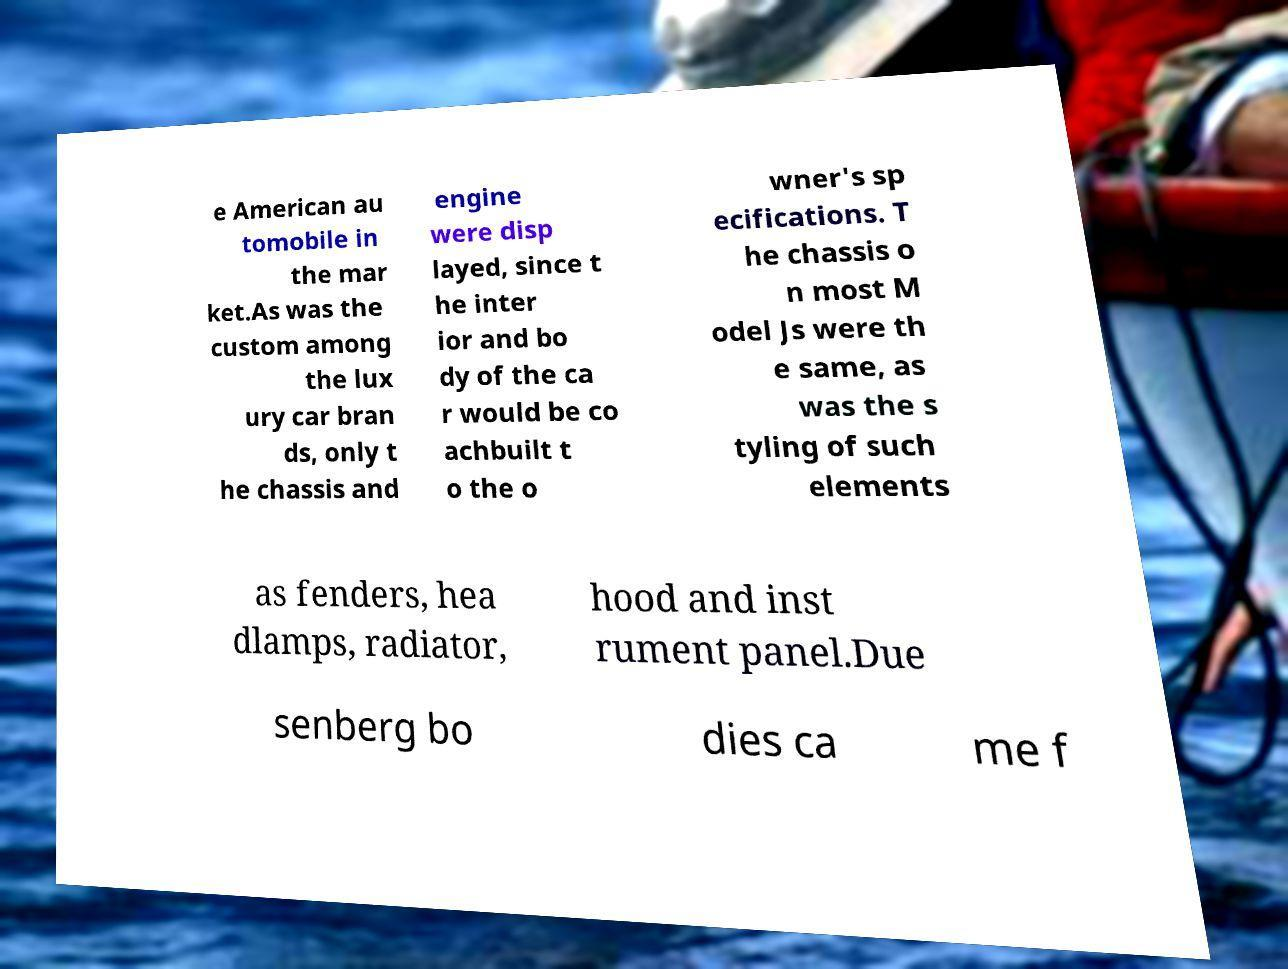Can you read and provide the text displayed in the image?This photo seems to have some interesting text. Can you extract and type it out for me? e American au tomobile in the mar ket.As was the custom among the lux ury car bran ds, only t he chassis and engine were disp layed, since t he inter ior and bo dy of the ca r would be co achbuilt t o the o wner's sp ecifications. T he chassis o n most M odel Js were th e same, as was the s tyling of such elements as fenders, hea dlamps, radiator, hood and inst rument panel.Due senberg bo dies ca me f 